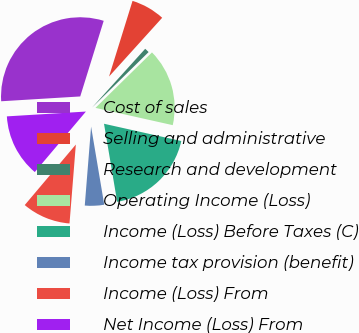Convert chart to OTSL. <chart><loc_0><loc_0><loc_500><loc_500><pie_chart><fcel>Cost of sales<fcel>Selling and administrative<fcel>Research and development<fcel>Operating Income (Loss)<fcel>Income (Loss) Before Taxes (C)<fcel>Income tax provision (benefit)<fcel>Income (Loss) From<fcel>Net Income (Loss) From<nl><fcel>30.76%<fcel>6.91%<fcel>0.95%<fcel>15.85%<fcel>18.84%<fcel>3.93%<fcel>9.89%<fcel>12.87%<nl></chart> 